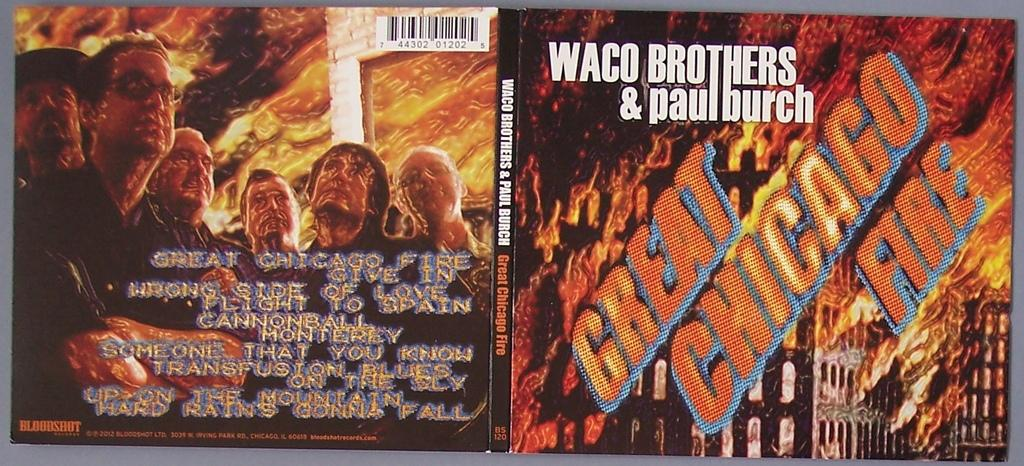<image>
Relay a brief, clear account of the picture shown. A CD cover with a city in flames for Waco Brothers & Paul Burch's Great Chicago Fire 